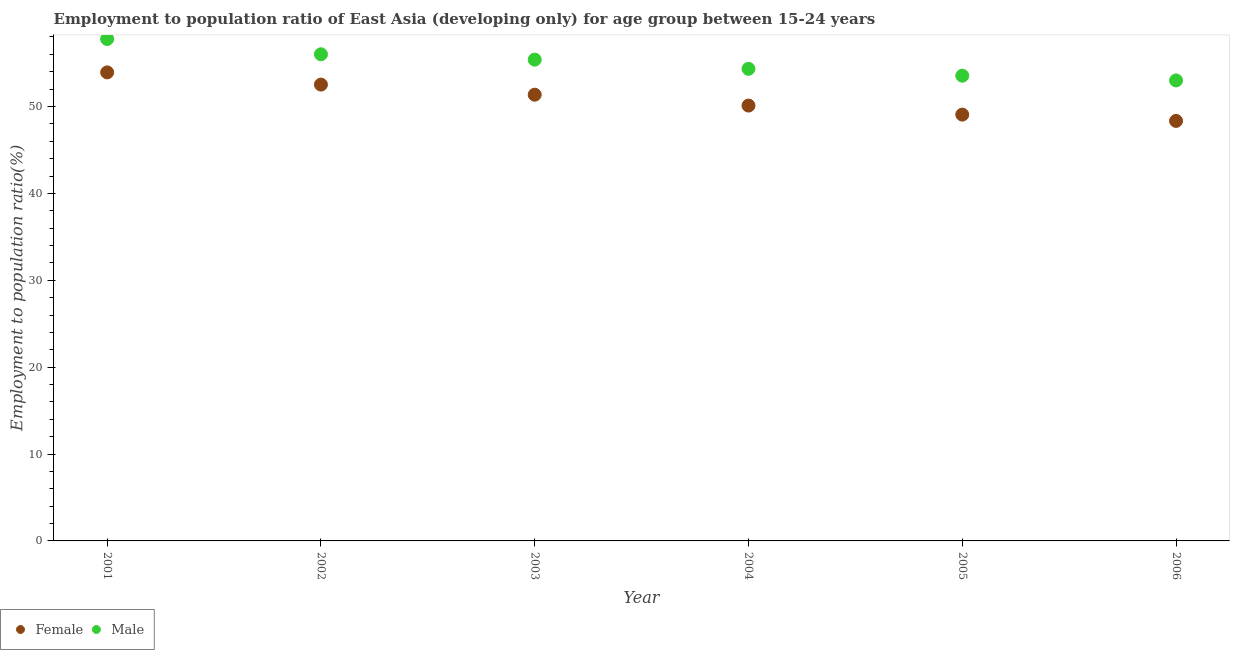How many different coloured dotlines are there?
Give a very brief answer. 2. Is the number of dotlines equal to the number of legend labels?
Make the answer very short. Yes. What is the employment to population ratio(male) in 2005?
Offer a terse response. 53.55. Across all years, what is the maximum employment to population ratio(male)?
Ensure brevity in your answer.  57.77. Across all years, what is the minimum employment to population ratio(male)?
Offer a terse response. 53. In which year was the employment to population ratio(female) minimum?
Provide a short and direct response. 2006. What is the total employment to population ratio(female) in the graph?
Provide a short and direct response. 305.32. What is the difference between the employment to population ratio(female) in 2005 and that in 2006?
Make the answer very short. 0.73. What is the difference between the employment to population ratio(male) in 2003 and the employment to population ratio(female) in 2004?
Your answer should be very brief. 5.29. What is the average employment to population ratio(male) per year?
Offer a terse response. 55.01. In the year 2006, what is the difference between the employment to population ratio(female) and employment to population ratio(male)?
Keep it short and to the point. -4.66. In how many years, is the employment to population ratio(female) greater than 2 %?
Provide a short and direct response. 6. What is the ratio of the employment to population ratio(female) in 2001 to that in 2002?
Provide a short and direct response. 1.03. Is the employment to population ratio(female) in 2001 less than that in 2005?
Make the answer very short. No. Is the difference between the employment to population ratio(male) in 2003 and 2004 greater than the difference between the employment to population ratio(female) in 2003 and 2004?
Your answer should be very brief. No. What is the difference between the highest and the second highest employment to population ratio(female)?
Offer a very short reply. 1.4. What is the difference between the highest and the lowest employment to population ratio(female)?
Offer a very short reply. 5.59. Is the sum of the employment to population ratio(female) in 2002 and 2006 greater than the maximum employment to population ratio(male) across all years?
Your response must be concise. Yes. Does the employment to population ratio(male) monotonically increase over the years?
Ensure brevity in your answer.  No. What is the difference between two consecutive major ticks on the Y-axis?
Provide a succinct answer. 10. Does the graph contain grids?
Offer a very short reply. No. How are the legend labels stacked?
Keep it short and to the point. Horizontal. What is the title of the graph?
Your answer should be compact. Employment to population ratio of East Asia (developing only) for age group between 15-24 years. Does "GDP at market prices" appear as one of the legend labels in the graph?
Offer a terse response. No. What is the label or title of the Y-axis?
Keep it short and to the point. Employment to population ratio(%). What is the Employment to population ratio(%) in Female in 2001?
Provide a short and direct response. 53.93. What is the Employment to population ratio(%) of Male in 2001?
Your response must be concise. 57.77. What is the Employment to population ratio(%) in Female in 2002?
Give a very brief answer. 52.52. What is the Employment to population ratio(%) in Male in 2002?
Your answer should be very brief. 56.01. What is the Employment to population ratio(%) in Female in 2003?
Your response must be concise. 51.36. What is the Employment to population ratio(%) of Male in 2003?
Your answer should be compact. 55.39. What is the Employment to population ratio(%) in Female in 2004?
Provide a succinct answer. 50.11. What is the Employment to population ratio(%) in Male in 2004?
Keep it short and to the point. 54.34. What is the Employment to population ratio(%) of Female in 2005?
Give a very brief answer. 49.07. What is the Employment to population ratio(%) of Male in 2005?
Your response must be concise. 53.55. What is the Employment to population ratio(%) in Female in 2006?
Give a very brief answer. 48.34. What is the Employment to population ratio(%) in Male in 2006?
Provide a short and direct response. 53. Across all years, what is the maximum Employment to population ratio(%) of Female?
Provide a succinct answer. 53.93. Across all years, what is the maximum Employment to population ratio(%) of Male?
Your answer should be very brief. 57.77. Across all years, what is the minimum Employment to population ratio(%) in Female?
Keep it short and to the point. 48.34. Across all years, what is the minimum Employment to population ratio(%) in Male?
Give a very brief answer. 53. What is the total Employment to population ratio(%) of Female in the graph?
Offer a terse response. 305.32. What is the total Employment to population ratio(%) of Male in the graph?
Your answer should be compact. 330.06. What is the difference between the Employment to population ratio(%) in Female in 2001 and that in 2002?
Offer a very short reply. 1.4. What is the difference between the Employment to population ratio(%) of Male in 2001 and that in 2002?
Offer a very short reply. 1.76. What is the difference between the Employment to population ratio(%) in Female in 2001 and that in 2003?
Give a very brief answer. 2.57. What is the difference between the Employment to population ratio(%) of Male in 2001 and that in 2003?
Give a very brief answer. 2.38. What is the difference between the Employment to population ratio(%) in Female in 2001 and that in 2004?
Provide a short and direct response. 3.82. What is the difference between the Employment to population ratio(%) of Male in 2001 and that in 2004?
Your answer should be very brief. 3.43. What is the difference between the Employment to population ratio(%) in Female in 2001 and that in 2005?
Provide a short and direct response. 4.86. What is the difference between the Employment to population ratio(%) of Male in 2001 and that in 2005?
Your answer should be compact. 4.23. What is the difference between the Employment to population ratio(%) in Female in 2001 and that in 2006?
Your answer should be compact. 5.59. What is the difference between the Employment to population ratio(%) in Male in 2001 and that in 2006?
Offer a terse response. 4.77. What is the difference between the Employment to population ratio(%) in Female in 2002 and that in 2003?
Your answer should be compact. 1.16. What is the difference between the Employment to population ratio(%) in Male in 2002 and that in 2003?
Your answer should be very brief. 0.62. What is the difference between the Employment to population ratio(%) of Female in 2002 and that in 2004?
Your answer should be very brief. 2.42. What is the difference between the Employment to population ratio(%) in Male in 2002 and that in 2004?
Your response must be concise. 1.67. What is the difference between the Employment to population ratio(%) of Female in 2002 and that in 2005?
Make the answer very short. 3.46. What is the difference between the Employment to population ratio(%) in Male in 2002 and that in 2005?
Your answer should be very brief. 2.46. What is the difference between the Employment to population ratio(%) in Female in 2002 and that in 2006?
Keep it short and to the point. 4.18. What is the difference between the Employment to population ratio(%) of Male in 2002 and that in 2006?
Give a very brief answer. 3.01. What is the difference between the Employment to population ratio(%) of Female in 2003 and that in 2004?
Ensure brevity in your answer.  1.25. What is the difference between the Employment to population ratio(%) of Male in 2003 and that in 2004?
Give a very brief answer. 1.06. What is the difference between the Employment to population ratio(%) in Female in 2003 and that in 2005?
Provide a short and direct response. 2.29. What is the difference between the Employment to population ratio(%) in Male in 2003 and that in 2005?
Your answer should be compact. 1.85. What is the difference between the Employment to population ratio(%) of Female in 2003 and that in 2006?
Keep it short and to the point. 3.02. What is the difference between the Employment to population ratio(%) of Male in 2003 and that in 2006?
Keep it short and to the point. 2.39. What is the difference between the Employment to population ratio(%) in Female in 2004 and that in 2005?
Provide a succinct answer. 1.04. What is the difference between the Employment to population ratio(%) of Male in 2004 and that in 2005?
Give a very brief answer. 0.79. What is the difference between the Employment to population ratio(%) in Female in 2004 and that in 2006?
Your answer should be compact. 1.77. What is the difference between the Employment to population ratio(%) in Male in 2004 and that in 2006?
Your response must be concise. 1.34. What is the difference between the Employment to population ratio(%) in Female in 2005 and that in 2006?
Make the answer very short. 0.73. What is the difference between the Employment to population ratio(%) in Male in 2005 and that in 2006?
Offer a terse response. 0.54. What is the difference between the Employment to population ratio(%) in Female in 2001 and the Employment to population ratio(%) in Male in 2002?
Make the answer very short. -2.08. What is the difference between the Employment to population ratio(%) of Female in 2001 and the Employment to population ratio(%) of Male in 2003?
Provide a short and direct response. -1.47. What is the difference between the Employment to population ratio(%) in Female in 2001 and the Employment to population ratio(%) in Male in 2004?
Keep it short and to the point. -0.41. What is the difference between the Employment to population ratio(%) in Female in 2001 and the Employment to population ratio(%) in Male in 2005?
Offer a terse response. 0.38. What is the difference between the Employment to population ratio(%) of Female in 2001 and the Employment to population ratio(%) of Male in 2006?
Ensure brevity in your answer.  0.93. What is the difference between the Employment to population ratio(%) in Female in 2002 and the Employment to population ratio(%) in Male in 2003?
Your response must be concise. -2.87. What is the difference between the Employment to population ratio(%) of Female in 2002 and the Employment to population ratio(%) of Male in 2004?
Provide a succinct answer. -1.82. What is the difference between the Employment to population ratio(%) in Female in 2002 and the Employment to population ratio(%) in Male in 2005?
Your answer should be compact. -1.02. What is the difference between the Employment to population ratio(%) of Female in 2002 and the Employment to population ratio(%) of Male in 2006?
Your answer should be compact. -0.48. What is the difference between the Employment to population ratio(%) in Female in 2003 and the Employment to population ratio(%) in Male in 2004?
Give a very brief answer. -2.98. What is the difference between the Employment to population ratio(%) in Female in 2003 and the Employment to population ratio(%) in Male in 2005?
Make the answer very short. -2.19. What is the difference between the Employment to population ratio(%) in Female in 2003 and the Employment to population ratio(%) in Male in 2006?
Give a very brief answer. -1.64. What is the difference between the Employment to population ratio(%) of Female in 2004 and the Employment to population ratio(%) of Male in 2005?
Offer a terse response. -3.44. What is the difference between the Employment to population ratio(%) in Female in 2004 and the Employment to population ratio(%) in Male in 2006?
Provide a succinct answer. -2.9. What is the difference between the Employment to population ratio(%) of Female in 2005 and the Employment to population ratio(%) of Male in 2006?
Your answer should be very brief. -3.93. What is the average Employment to population ratio(%) of Female per year?
Give a very brief answer. 50.89. What is the average Employment to population ratio(%) of Male per year?
Give a very brief answer. 55.01. In the year 2001, what is the difference between the Employment to population ratio(%) of Female and Employment to population ratio(%) of Male?
Make the answer very short. -3.85. In the year 2002, what is the difference between the Employment to population ratio(%) of Female and Employment to population ratio(%) of Male?
Give a very brief answer. -3.49. In the year 2003, what is the difference between the Employment to population ratio(%) in Female and Employment to population ratio(%) in Male?
Ensure brevity in your answer.  -4.03. In the year 2004, what is the difference between the Employment to population ratio(%) of Female and Employment to population ratio(%) of Male?
Your response must be concise. -4.23. In the year 2005, what is the difference between the Employment to population ratio(%) in Female and Employment to population ratio(%) in Male?
Provide a short and direct response. -4.48. In the year 2006, what is the difference between the Employment to population ratio(%) of Female and Employment to population ratio(%) of Male?
Provide a short and direct response. -4.66. What is the ratio of the Employment to population ratio(%) in Female in 2001 to that in 2002?
Ensure brevity in your answer.  1.03. What is the ratio of the Employment to population ratio(%) of Male in 2001 to that in 2002?
Make the answer very short. 1.03. What is the ratio of the Employment to population ratio(%) of Male in 2001 to that in 2003?
Your answer should be compact. 1.04. What is the ratio of the Employment to population ratio(%) of Female in 2001 to that in 2004?
Your response must be concise. 1.08. What is the ratio of the Employment to population ratio(%) of Male in 2001 to that in 2004?
Provide a succinct answer. 1.06. What is the ratio of the Employment to population ratio(%) of Female in 2001 to that in 2005?
Ensure brevity in your answer.  1.1. What is the ratio of the Employment to population ratio(%) in Male in 2001 to that in 2005?
Offer a terse response. 1.08. What is the ratio of the Employment to population ratio(%) in Female in 2001 to that in 2006?
Provide a succinct answer. 1.12. What is the ratio of the Employment to population ratio(%) in Male in 2001 to that in 2006?
Make the answer very short. 1.09. What is the ratio of the Employment to population ratio(%) of Female in 2002 to that in 2003?
Offer a very short reply. 1.02. What is the ratio of the Employment to population ratio(%) of Male in 2002 to that in 2003?
Keep it short and to the point. 1.01. What is the ratio of the Employment to population ratio(%) in Female in 2002 to that in 2004?
Offer a very short reply. 1.05. What is the ratio of the Employment to population ratio(%) of Male in 2002 to that in 2004?
Keep it short and to the point. 1.03. What is the ratio of the Employment to population ratio(%) in Female in 2002 to that in 2005?
Keep it short and to the point. 1.07. What is the ratio of the Employment to population ratio(%) in Male in 2002 to that in 2005?
Ensure brevity in your answer.  1.05. What is the ratio of the Employment to population ratio(%) of Female in 2002 to that in 2006?
Keep it short and to the point. 1.09. What is the ratio of the Employment to population ratio(%) of Male in 2002 to that in 2006?
Keep it short and to the point. 1.06. What is the ratio of the Employment to population ratio(%) in Female in 2003 to that in 2004?
Keep it short and to the point. 1.02. What is the ratio of the Employment to population ratio(%) in Male in 2003 to that in 2004?
Provide a short and direct response. 1.02. What is the ratio of the Employment to population ratio(%) of Female in 2003 to that in 2005?
Offer a terse response. 1.05. What is the ratio of the Employment to population ratio(%) in Male in 2003 to that in 2005?
Your answer should be compact. 1.03. What is the ratio of the Employment to population ratio(%) in Female in 2003 to that in 2006?
Offer a terse response. 1.06. What is the ratio of the Employment to population ratio(%) of Male in 2003 to that in 2006?
Provide a succinct answer. 1.05. What is the ratio of the Employment to population ratio(%) of Female in 2004 to that in 2005?
Your response must be concise. 1.02. What is the ratio of the Employment to population ratio(%) of Male in 2004 to that in 2005?
Give a very brief answer. 1.01. What is the ratio of the Employment to population ratio(%) in Female in 2004 to that in 2006?
Provide a short and direct response. 1.04. What is the ratio of the Employment to population ratio(%) of Male in 2004 to that in 2006?
Offer a very short reply. 1.03. What is the ratio of the Employment to population ratio(%) of Female in 2005 to that in 2006?
Offer a very short reply. 1.01. What is the ratio of the Employment to population ratio(%) of Male in 2005 to that in 2006?
Ensure brevity in your answer.  1.01. What is the difference between the highest and the second highest Employment to population ratio(%) in Female?
Give a very brief answer. 1.4. What is the difference between the highest and the second highest Employment to population ratio(%) of Male?
Keep it short and to the point. 1.76. What is the difference between the highest and the lowest Employment to population ratio(%) of Female?
Provide a succinct answer. 5.59. What is the difference between the highest and the lowest Employment to population ratio(%) of Male?
Offer a terse response. 4.77. 